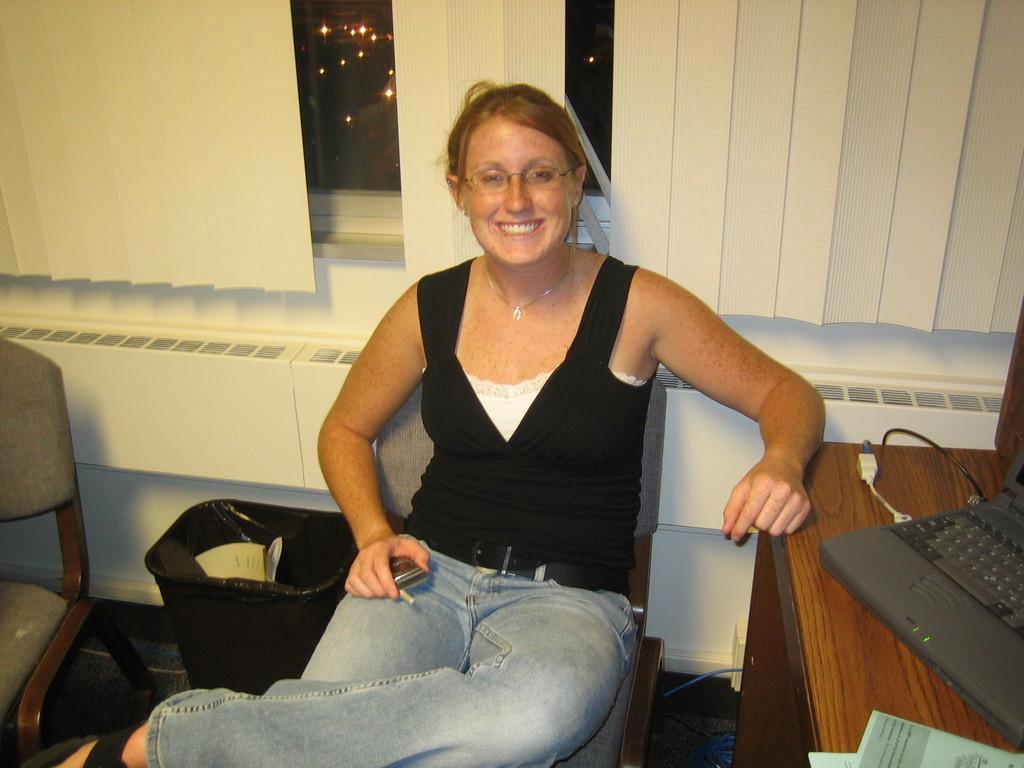How would you summarize this image in a sentence or two? In the picture we can find a woman sitting on a chair and holding a table. In the background we can find a wall, a window and a white curtain. Beside to her we can find another chair and dust bin. On the table we can find a monitor. 